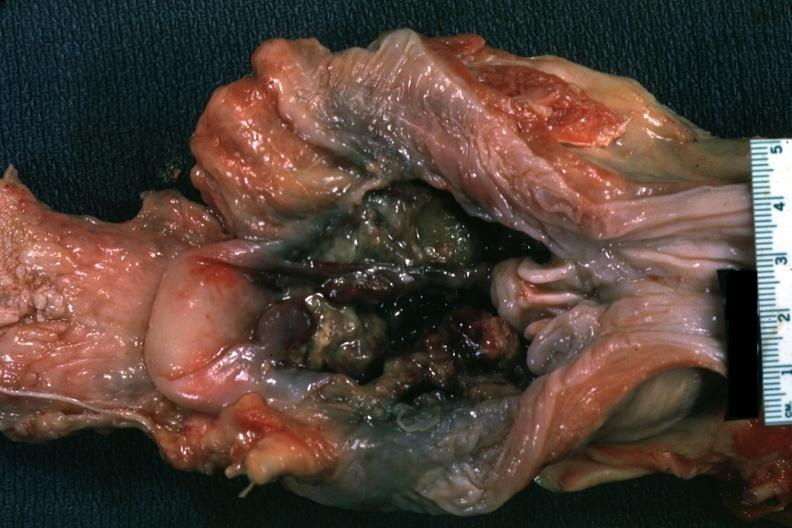what is present?
Answer the question using a single word or phrase. Oral 